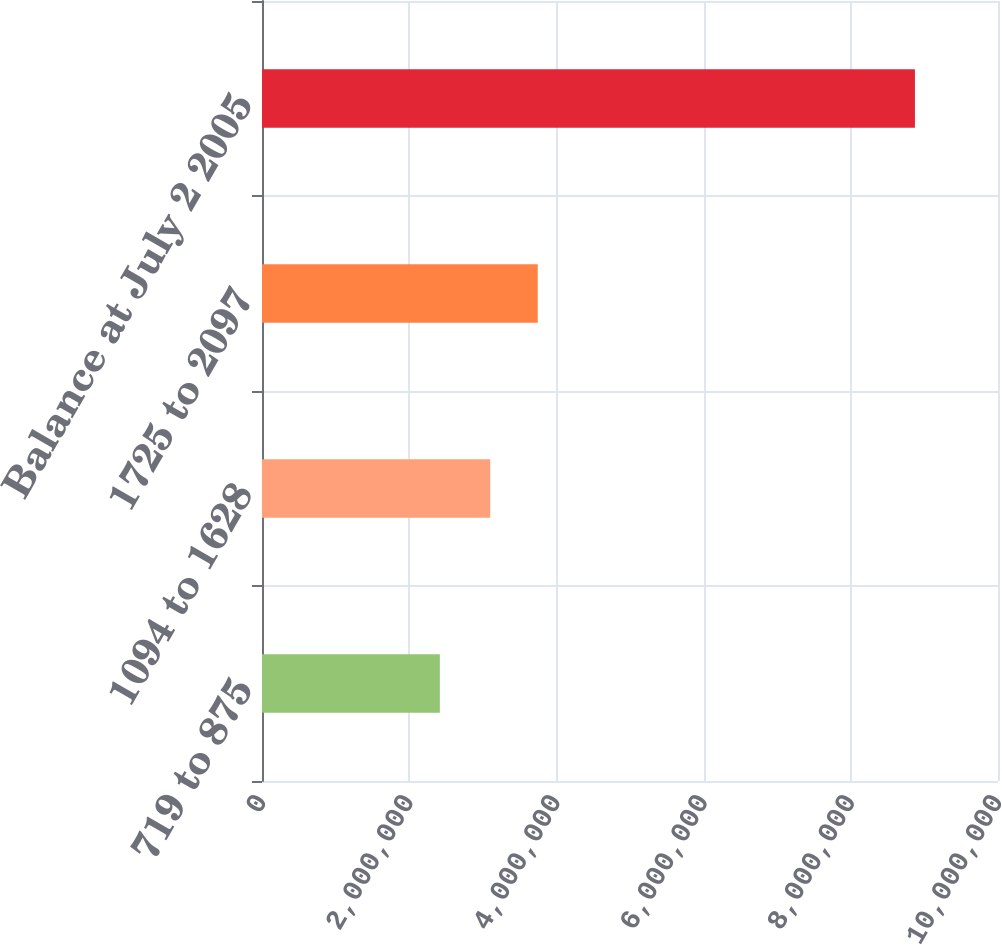Convert chart to OTSL. <chart><loc_0><loc_0><loc_500><loc_500><bar_chart><fcel>719 to 875<fcel>1094 to 1628<fcel>1725 to 2097<fcel>Balance at July 2 2005<nl><fcel>2.41625e+06<fcel>3.10086e+06<fcel>3.74638e+06<fcel>8.87143e+06<nl></chart> 